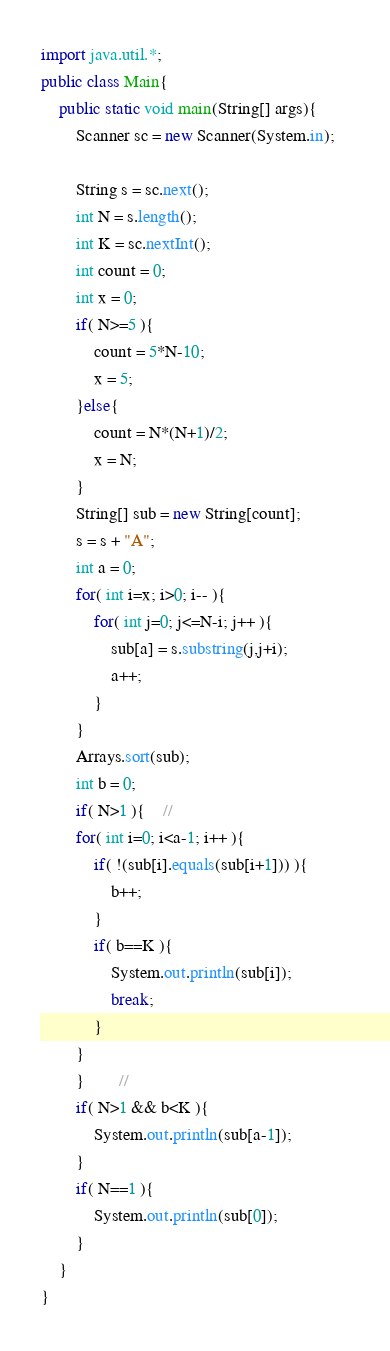<code> <loc_0><loc_0><loc_500><loc_500><_Java_>import java.util.*;
public class Main{
	public static void main(String[] args){
		Scanner sc = new Scanner(System.in);

		String s = sc.next();
		int N = s.length();
		int K = sc.nextInt();
		int count = 0;
		int x = 0;
		if( N>=5 ){
			count = 5*N-10;
			x = 5;
		}else{
			count = N*(N+1)/2;
			x = N;
		}
		String[] sub = new String[count];
		s = s + "A";
		int a = 0;
		for( int i=x; i>0; i-- ){        
			for( int j=0; j<=N-i; j++ ){
				sub[a] = s.substring(j,j+i);
				a++;              
			}
		}     
		Arrays.sort(sub);
		int b = 0;  
		if( N>1 ){	//
		for( int i=0; i<a-1; i++ ){  
			if( !(sub[i].equals(sub[i+1])) ){
				b++;
			}      
			if( b==K ){
				System.out.println(sub[i]);             
				break;
			}
		}  
		}  		// 
		if( N>1 && b<K ){
			System.out.println(sub[a-1]);          
        }          
		if( N==1 ){
			System.out.println(sub[0]);
		} 
	}
}
</code> 